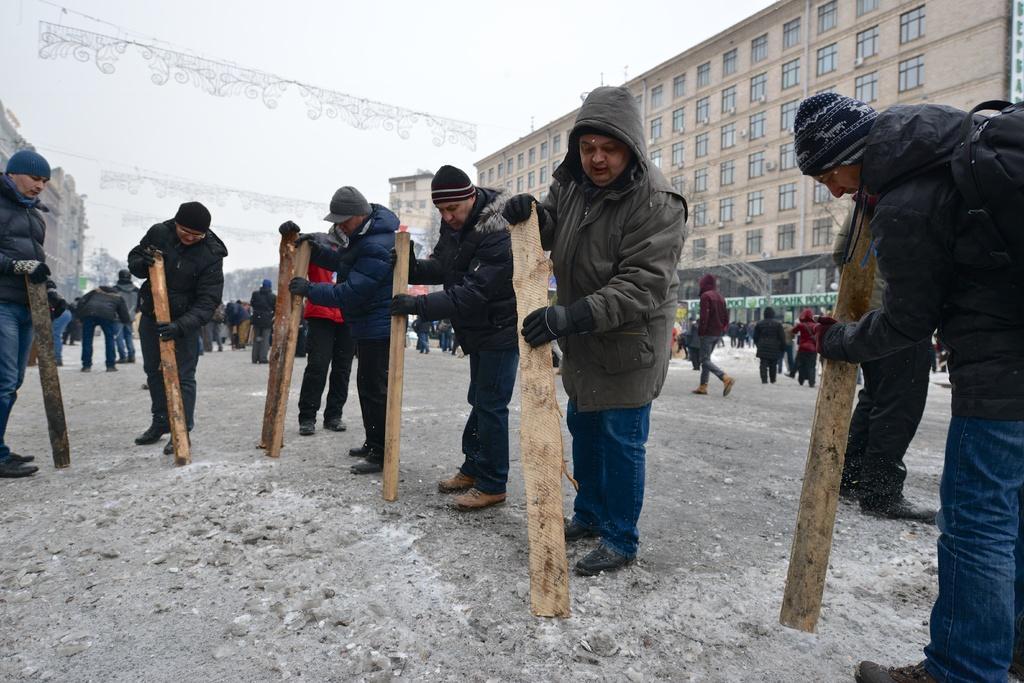Describe this image in one or two sentences. In this image we can see few people wearing caps and gloves. They are holding wooden objects. In the back there are many people. Also there are buildings with windows. And there are decorative items. In the background there is sky. 